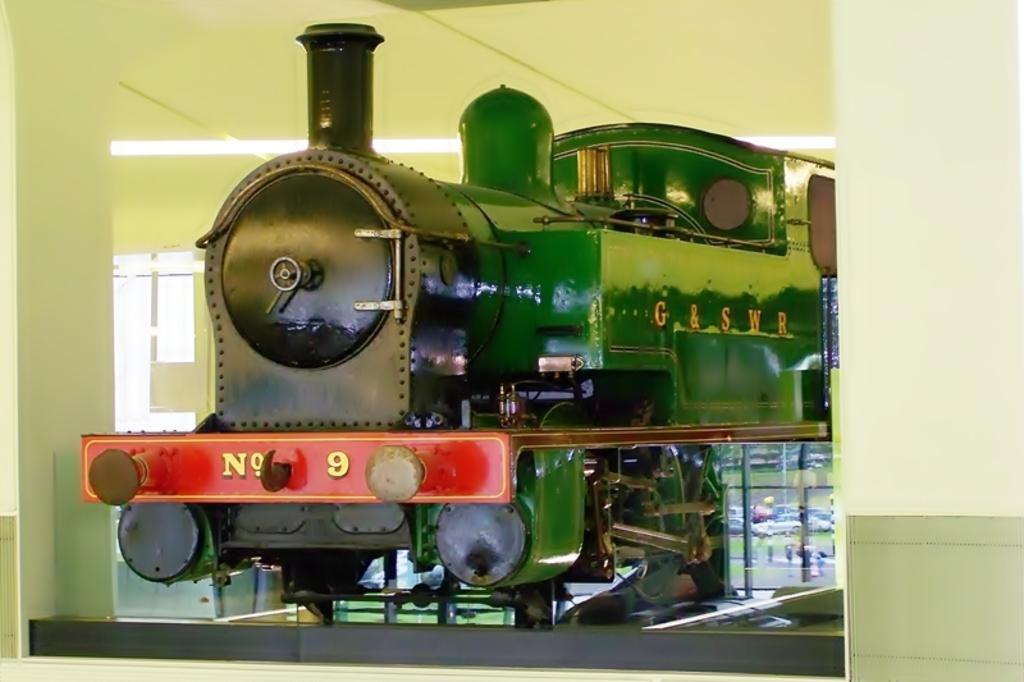Describe this image in one or two sentences. In this picture I can see there is a train engine placed in a display and in the backdrop there is a glass window and a wall. 